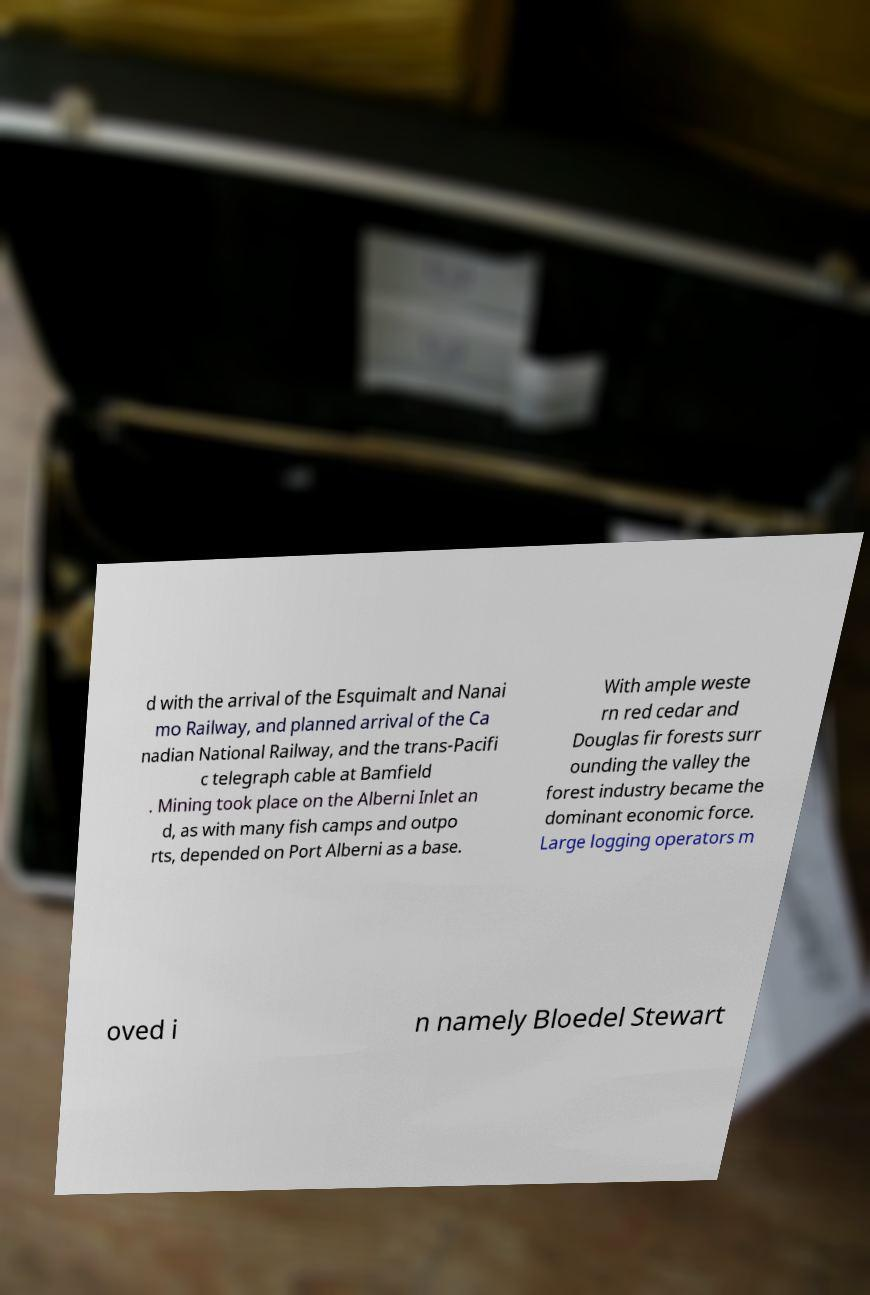Can you accurately transcribe the text from the provided image for me? d with the arrival of the Esquimalt and Nanai mo Railway, and planned arrival of the Ca nadian National Railway, and the trans-Pacifi c telegraph cable at Bamfield . Mining took place on the Alberni Inlet an d, as with many fish camps and outpo rts, depended on Port Alberni as a base. With ample weste rn red cedar and Douglas fir forests surr ounding the valley the forest industry became the dominant economic force. Large logging operators m oved i n namely Bloedel Stewart 